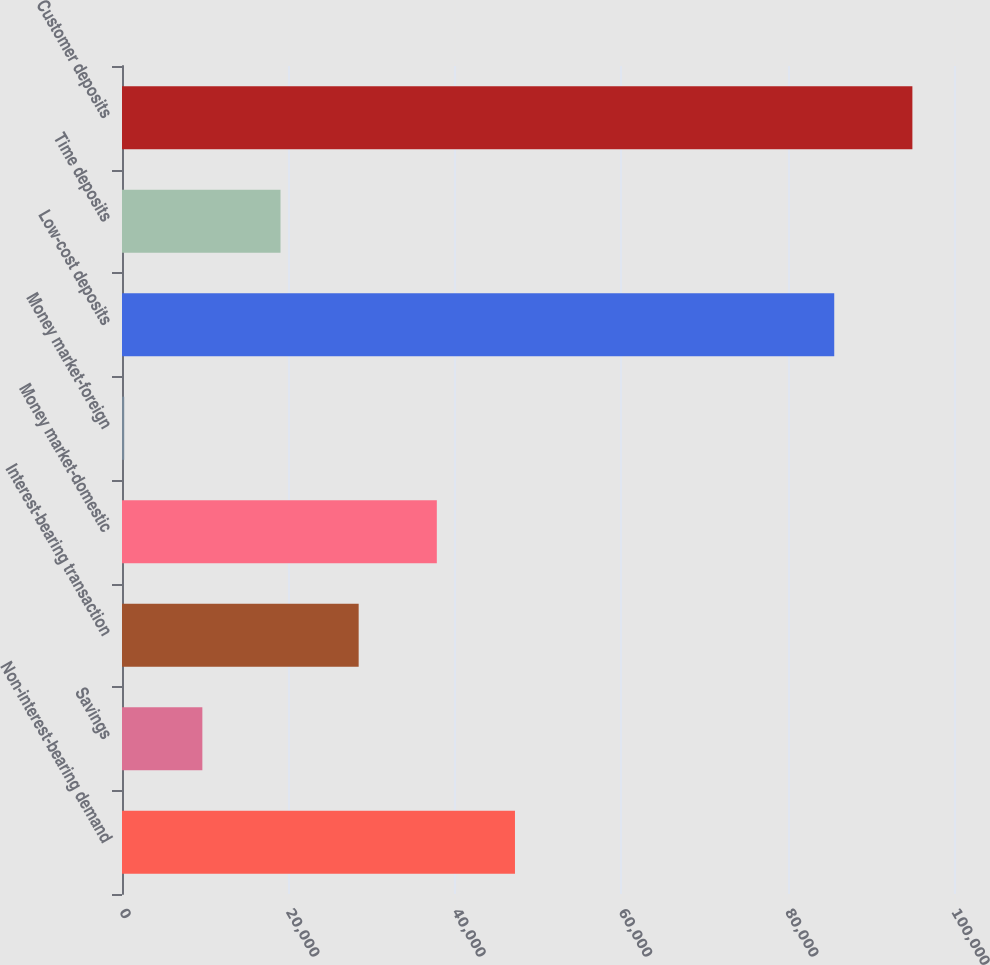<chart> <loc_0><loc_0><loc_500><loc_500><bar_chart><fcel>Non-interest-bearing demand<fcel>Savings<fcel>Interest-bearing transaction<fcel>Money market-domestic<fcel>Money market-foreign<fcel>Low-cost deposits<fcel>Time deposits<fcel>Customer deposits<nl><fcel>47232.5<fcel>9658.5<fcel>28445.5<fcel>37839<fcel>265<fcel>85605<fcel>19052<fcel>94998.5<nl></chart> 